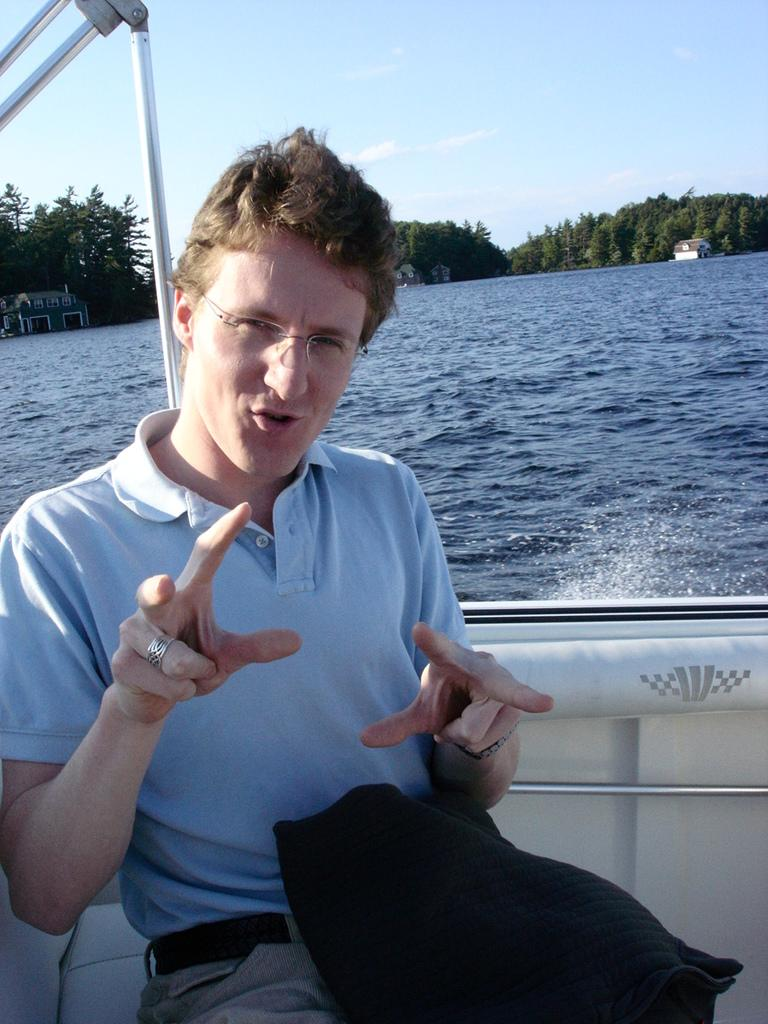What is the man in the image doing? The man is sitting in a boat in the image. What can be seen in the background of the image? There are trees and house structures in the background of the image. What is the primary setting of the image? The primary setting of the image is water, as the man is sitting in a boat. What else is visible in the background of the image? The sky is visible in the background of the image. What type of silver material is present in the image? There is no silver material present in the image. What kind of fruit can be seen growing on the trees in the image? There are no trees with fruit visible in the image; only trees without fruit are present. 